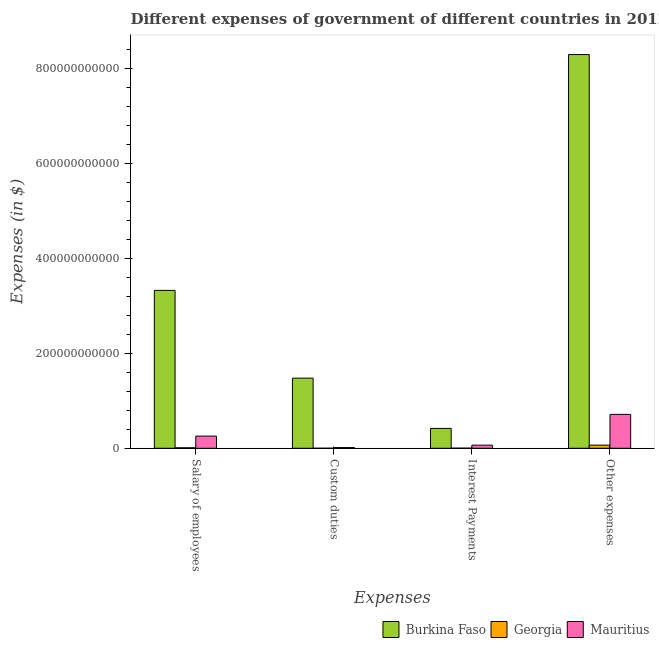Are the number of bars on each tick of the X-axis equal?
Your answer should be very brief. Yes. How many bars are there on the 4th tick from the right?
Ensure brevity in your answer.  3. What is the label of the 4th group of bars from the left?
Your response must be concise. Other expenses. What is the amount spent on salary of employees in Burkina Faso?
Ensure brevity in your answer.  3.32e+11. Across all countries, what is the maximum amount spent on salary of employees?
Your response must be concise. 3.32e+11. Across all countries, what is the minimum amount spent on other expenses?
Offer a terse response. 6.64e+09. In which country was the amount spent on salary of employees maximum?
Keep it short and to the point. Burkina Faso. In which country was the amount spent on custom duties minimum?
Provide a short and direct response. Georgia. What is the total amount spent on salary of employees in the graph?
Make the answer very short. 3.59e+11. What is the difference between the amount spent on custom duties in Georgia and that in Mauritius?
Ensure brevity in your answer.  -1.42e+09. What is the difference between the amount spent on salary of employees in Georgia and the amount spent on other expenses in Mauritius?
Make the answer very short. -7.03e+1. What is the average amount spent on interest payments per country?
Your response must be concise. 1.62e+1. What is the difference between the amount spent on interest payments and amount spent on custom duties in Burkina Faso?
Offer a very short reply. -1.06e+11. In how many countries, is the amount spent on salary of employees greater than 440000000000 $?
Provide a succinct answer. 0. What is the ratio of the amount spent on salary of employees in Georgia to that in Mauritius?
Offer a very short reply. 0.04. Is the difference between the amount spent on other expenses in Burkina Faso and Georgia greater than the difference between the amount spent on salary of employees in Burkina Faso and Georgia?
Give a very brief answer. Yes. What is the difference between the highest and the second highest amount spent on salary of employees?
Provide a short and direct response. 3.07e+11. What is the difference between the highest and the lowest amount spent on other expenses?
Your answer should be compact. 8.22e+11. In how many countries, is the amount spent on other expenses greater than the average amount spent on other expenses taken over all countries?
Make the answer very short. 1. Is the sum of the amount spent on salary of employees in Burkina Faso and Georgia greater than the maximum amount spent on interest payments across all countries?
Make the answer very short. Yes. Is it the case that in every country, the sum of the amount spent on custom duties and amount spent on interest payments is greater than the sum of amount spent on salary of employees and amount spent on other expenses?
Provide a succinct answer. No. What does the 1st bar from the left in Other expenses represents?
Provide a succinct answer. Burkina Faso. What does the 1st bar from the right in Other expenses represents?
Keep it short and to the point. Mauritius. How many bars are there?
Keep it short and to the point. 12. How many countries are there in the graph?
Provide a short and direct response. 3. What is the difference between two consecutive major ticks on the Y-axis?
Ensure brevity in your answer.  2.00e+11. Are the values on the major ticks of Y-axis written in scientific E-notation?
Offer a terse response. No. Does the graph contain grids?
Make the answer very short. No. Where does the legend appear in the graph?
Ensure brevity in your answer.  Bottom right. How are the legend labels stacked?
Give a very brief answer. Horizontal. What is the title of the graph?
Offer a terse response. Different expenses of government of different countries in 2012. Does "Lao PDR" appear as one of the legend labels in the graph?
Provide a succinct answer. No. What is the label or title of the X-axis?
Make the answer very short. Expenses. What is the label or title of the Y-axis?
Offer a terse response. Expenses (in $). What is the Expenses (in $) of Burkina Faso in Salary of employees?
Make the answer very short. 3.32e+11. What is the Expenses (in $) of Georgia in Salary of employees?
Keep it short and to the point. 1.05e+09. What is the Expenses (in $) of Mauritius in Salary of employees?
Give a very brief answer. 2.57e+1. What is the Expenses (in $) in Burkina Faso in Custom duties?
Your response must be concise. 1.48e+11. What is the Expenses (in $) in Georgia in Custom duties?
Make the answer very short. 9.01e+07. What is the Expenses (in $) of Mauritius in Custom duties?
Provide a succinct answer. 1.51e+09. What is the Expenses (in $) in Burkina Faso in Interest Payments?
Your answer should be compact. 4.18e+1. What is the Expenses (in $) of Georgia in Interest Payments?
Give a very brief answer. 2.48e+08. What is the Expenses (in $) in Mauritius in Interest Payments?
Your answer should be compact. 6.61e+09. What is the Expenses (in $) of Burkina Faso in Other expenses?
Make the answer very short. 8.29e+11. What is the Expenses (in $) of Georgia in Other expenses?
Give a very brief answer. 6.64e+09. What is the Expenses (in $) in Mauritius in Other expenses?
Provide a succinct answer. 7.14e+1. Across all Expenses, what is the maximum Expenses (in $) in Burkina Faso?
Provide a succinct answer. 8.29e+11. Across all Expenses, what is the maximum Expenses (in $) in Georgia?
Provide a succinct answer. 6.64e+09. Across all Expenses, what is the maximum Expenses (in $) of Mauritius?
Make the answer very short. 7.14e+1. Across all Expenses, what is the minimum Expenses (in $) in Burkina Faso?
Make the answer very short. 4.18e+1. Across all Expenses, what is the minimum Expenses (in $) of Georgia?
Give a very brief answer. 9.01e+07. Across all Expenses, what is the minimum Expenses (in $) in Mauritius?
Offer a terse response. 1.51e+09. What is the total Expenses (in $) in Burkina Faso in the graph?
Give a very brief answer. 1.35e+12. What is the total Expenses (in $) of Georgia in the graph?
Your answer should be very brief. 8.03e+09. What is the total Expenses (in $) of Mauritius in the graph?
Make the answer very short. 1.05e+11. What is the difference between the Expenses (in $) of Burkina Faso in Salary of employees and that in Custom duties?
Your answer should be very brief. 1.85e+11. What is the difference between the Expenses (in $) of Georgia in Salary of employees and that in Custom duties?
Your answer should be very brief. 9.59e+08. What is the difference between the Expenses (in $) in Mauritius in Salary of employees and that in Custom duties?
Provide a short and direct response. 2.42e+1. What is the difference between the Expenses (in $) in Burkina Faso in Salary of employees and that in Interest Payments?
Your response must be concise. 2.91e+11. What is the difference between the Expenses (in $) in Georgia in Salary of employees and that in Interest Payments?
Your response must be concise. 8.01e+08. What is the difference between the Expenses (in $) of Mauritius in Salary of employees and that in Interest Payments?
Keep it short and to the point. 1.91e+1. What is the difference between the Expenses (in $) of Burkina Faso in Salary of employees and that in Other expenses?
Give a very brief answer. -4.96e+11. What is the difference between the Expenses (in $) in Georgia in Salary of employees and that in Other expenses?
Ensure brevity in your answer.  -5.59e+09. What is the difference between the Expenses (in $) of Mauritius in Salary of employees and that in Other expenses?
Make the answer very short. -4.57e+1. What is the difference between the Expenses (in $) in Burkina Faso in Custom duties and that in Interest Payments?
Offer a very short reply. 1.06e+11. What is the difference between the Expenses (in $) in Georgia in Custom duties and that in Interest Payments?
Your answer should be very brief. -1.58e+08. What is the difference between the Expenses (in $) in Mauritius in Custom duties and that in Interest Payments?
Offer a very short reply. -5.10e+09. What is the difference between the Expenses (in $) in Burkina Faso in Custom duties and that in Other expenses?
Offer a very short reply. -6.81e+11. What is the difference between the Expenses (in $) of Georgia in Custom duties and that in Other expenses?
Keep it short and to the point. -6.55e+09. What is the difference between the Expenses (in $) in Mauritius in Custom duties and that in Other expenses?
Make the answer very short. -6.99e+1. What is the difference between the Expenses (in $) of Burkina Faso in Interest Payments and that in Other expenses?
Your answer should be very brief. -7.87e+11. What is the difference between the Expenses (in $) in Georgia in Interest Payments and that in Other expenses?
Provide a short and direct response. -6.39e+09. What is the difference between the Expenses (in $) of Mauritius in Interest Payments and that in Other expenses?
Offer a terse response. -6.48e+1. What is the difference between the Expenses (in $) of Burkina Faso in Salary of employees and the Expenses (in $) of Georgia in Custom duties?
Give a very brief answer. 3.32e+11. What is the difference between the Expenses (in $) in Burkina Faso in Salary of employees and the Expenses (in $) in Mauritius in Custom duties?
Your response must be concise. 3.31e+11. What is the difference between the Expenses (in $) in Georgia in Salary of employees and the Expenses (in $) in Mauritius in Custom duties?
Make the answer very short. -4.56e+08. What is the difference between the Expenses (in $) of Burkina Faso in Salary of employees and the Expenses (in $) of Georgia in Interest Payments?
Provide a succinct answer. 3.32e+11. What is the difference between the Expenses (in $) in Burkina Faso in Salary of employees and the Expenses (in $) in Mauritius in Interest Payments?
Provide a succinct answer. 3.26e+11. What is the difference between the Expenses (in $) of Georgia in Salary of employees and the Expenses (in $) of Mauritius in Interest Payments?
Offer a very short reply. -5.56e+09. What is the difference between the Expenses (in $) of Burkina Faso in Salary of employees and the Expenses (in $) of Georgia in Other expenses?
Your response must be concise. 3.26e+11. What is the difference between the Expenses (in $) in Burkina Faso in Salary of employees and the Expenses (in $) in Mauritius in Other expenses?
Your answer should be very brief. 2.61e+11. What is the difference between the Expenses (in $) of Georgia in Salary of employees and the Expenses (in $) of Mauritius in Other expenses?
Offer a very short reply. -7.03e+1. What is the difference between the Expenses (in $) of Burkina Faso in Custom duties and the Expenses (in $) of Georgia in Interest Payments?
Your answer should be very brief. 1.47e+11. What is the difference between the Expenses (in $) in Burkina Faso in Custom duties and the Expenses (in $) in Mauritius in Interest Payments?
Offer a very short reply. 1.41e+11. What is the difference between the Expenses (in $) of Georgia in Custom duties and the Expenses (in $) of Mauritius in Interest Payments?
Provide a succinct answer. -6.52e+09. What is the difference between the Expenses (in $) in Burkina Faso in Custom duties and the Expenses (in $) in Georgia in Other expenses?
Provide a short and direct response. 1.41e+11. What is the difference between the Expenses (in $) in Burkina Faso in Custom duties and the Expenses (in $) in Mauritius in Other expenses?
Offer a very short reply. 7.63e+1. What is the difference between the Expenses (in $) of Georgia in Custom duties and the Expenses (in $) of Mauritius in Other expenses?
Make the answer very short. -7.13e+1. What is the difference between the Expenses (in $) in Burkina Faso in Interest Payments and the Expenses (in $) in Georgia in Other expenses?
Make the answer very short. 3.52e+1. What is the difference between the Expenses (in $) of Burkina Faso in Interest Payments and the Expenses (in $) of Mauritius in Other expenses?
Keep it short and to the point. -2.96e+1. What is the difference between the Expenses (in $) of Georgia in Interest Payments and the Expenses (in $) of Mauritius in Other expenses?
Provide a short and direct response. -7.11e+1. What is the average Expenses (in $) in Burkina Faso per Expenses?
Provide a succinct answer. 3.38e+11. What is the average Expenses (in $) of Georgia per Expenses?
Ensure brevity in your answer.  2.01e+09. What is the average Expenses (in $) of Mauritius per Expenses?
Your answer should be compact. 2.63e+1. What is the difference between the Expenses (in $) in Burkina Faso and Expenses (in $) in Georgia in Salary of employees?
Your answer should be very brief. 3.31e+11. What is the difference between the Expenses (in $) in Burkina Faso and Expenses (in $) in Mauritius in Salary of employees?
Offer a terse response. 3.07e+11. What is the difference between the Expenses (in $) of Georgia and Expenses (in $) of Mauritius in Salary of employees?
Ensure brevity in your answer.  -2.46e+1. What is the difference between the Expenses (in $) of Burkina Faso and Expenses (in $) of Georgia in Custom duties?
Provide a succinct answer. 1.48e+11. What is the difference between the Expenses (in $) in Burkina Faso and Expenses (in $) in Mauritius in Custom duties?
Your answer should be very brief. 1.46e+11. What is the difference between the Expenses (in $) in Georgia and Expenses (in $) in Mauritius in Custom duties?
Provide a succinct answer. -1.42e+09. What is the difference between the Expenses (in $) in Burkina Faso and Expenses (in $) in Georgia in Interest Payments?
Provide a succinct answer. 4.16e+1. What is the difference between the Expenses (in $) of Burkina Faso and Expenses (in $) of Mauritius in Interest Payments?
Make the answer very short. 3.52e+1. What is the difference between the Expenses (in $) of Georgia and Expenses (in $) of Mauritius in Interest Payments?
Your response must be concise. -6.36e+09. What is the difference between the Expenses (in $) in Burkina Faso and Expenses (in $) in Georgia in Other expenses?
Give a very brief answer. 8.22e+11. What is the difference between the Expenses (in $) in Burkina Faso and Expenses (in $) in Mauritius in Other expenses?
Offer a terse response. 7.57e+11. What is the difference between the Expenses (in $) of Georgia and Expenses (in $) of Mauritius in Other expenses?
Provide a succinct answer. -6.47e+1. What is the ratio of the Expenses (in $) of Burkina Faso in Salary of employees to that in Custom duties?
Keep it short and to the point. 2.25. What is the ratio of the Expenses (in $) in Georgia in Salary of employees to that in Custom duties?
Keep it short and to the point. 11.65. What is the ratio of the Expenses (in $) of Mauritius in Salary of employees to that in Custom duties?
Keep it short and to the point. 17.04. What is the ratio of the Expenses (in $) in Burkina Faso in Salary of employees to that in Interest Payments?
Give a very brief answer. 7.95. What is the ratio of the Expenses (in $) in Georgia in Salary of employees to that in Interest Payments?
Ensure brevity in your answer.  4.23. What is the ratio of the Expenses (in $) of Mauritius in Salary of employees to that in Interest Payments?
Provide a succinct answer. 3.88. What is the ratio of the Expenses (in $) in Burkina Faso in Salary of employees to that in Other expenses?
Your response must be concise. 0.4. What is the ratio of the Expenses (in $) in Georgia in Salary of employees to that in Other expenses?
Make the answer very short. 0.16. What is the ratio of the Expenses (in $) of Mauritius in Salary of employees to that in Other expenses?
Your answer should be compact. 0.36. What is the ratio of the Expenses (in $) of Burkina Faso in Custom duties to that in Interest Payments?
Ensure brevity in your answer.  3.53. What is the ratio of the Expenses (in $) in Georgia in Custom duties to that in Interest Payments?
Offer a very short reply. 0.36. What is the ratio of the Expenses (in $) in Mauritius in Custom duties to that in Interest Payments?
Offer a very short reply. 0.23. What is the ratio of the Expenses (in $) in Burkina Faso in Custom duties to that in Other expenses?
Offer a terse response. 0.18. What is the ratio of the Expenses (in $) in Georgia in Custom duties to that in Other expenses?
Give a very brief answer. 0.01. What is the ratio of the Expenses (in $) of Mauritius in Custom duties to that in Other expenses?
Your response must be concise. 0.02. What is the ratio of the Expenses (in $) of Burkina Faso in Interest Payments to that in Other expenses?
Keep it short and to the point. 0.05. What is the ratio of the Expenses (in $) of Georgia in Interest Payments to that in Other expenses?
Make the answer very short. 0.04. What is the ratio of the Expenses (in $) in Mauritius in Interest Payments to that in Other expenses?
Provide a short and direct response. 0.09. What is the difference between the highest and the second highest Expenses (in $) in Burkina Faso?
Your response must be concise. 4.96e+11. What is the difference between the highest and the second highest Expenses (in $) in Georgia?
Keep it short and to the point. 5.59e+09. What is the difference between the highest and the second highest Expenses (in $) in Mauritius?
Your answer should be compact. 4.57e+1. What is the difference between the highest and the lowest Expenses (in $) in Burkina Faso?
Ensure brevity in your answer.  7.87e+11. What is the difference between the highest and the lowest Expenses (in $) of Georgia?
Make the answer very short. 6.55e+09. What is the difference between the highest and the lowest Expenses (in $) in Mauritius?
Keep it short and to the point. 6.99e+1. 